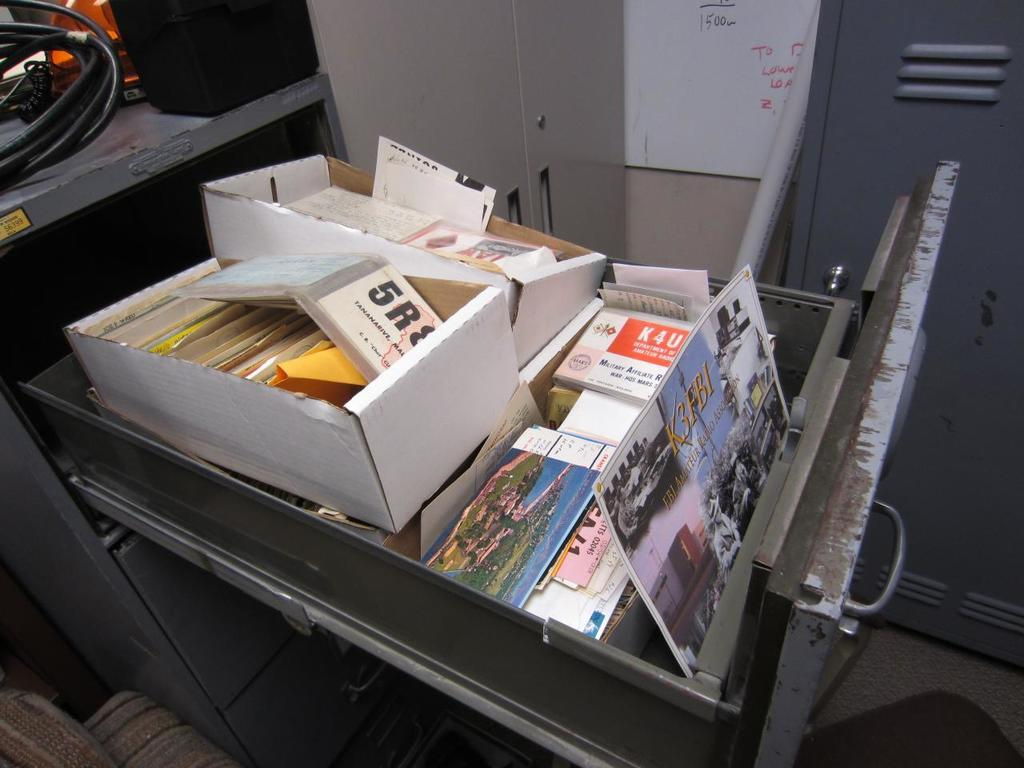<image>
Render a clear and concise summary of the photo. an open drawer with a picture and the letters 'k3fbi' on it 